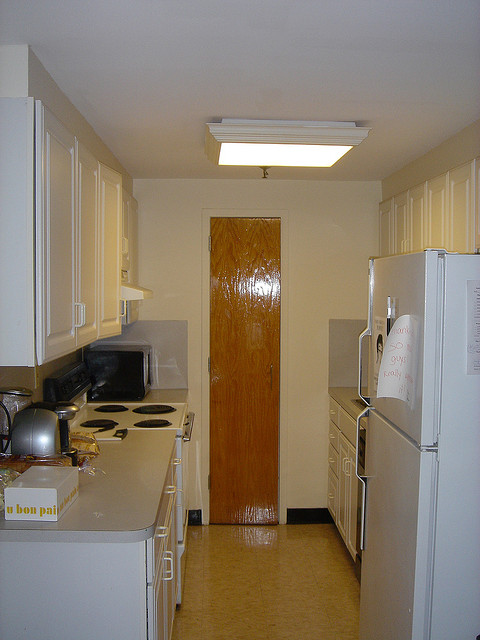<image>Are the curtains long or short? There are no curtains in the image. However, if there were, they could be either long or short. Are the curtains long or short? I don't know if the curtains are long or short. It can be seen both long and short curtains. 